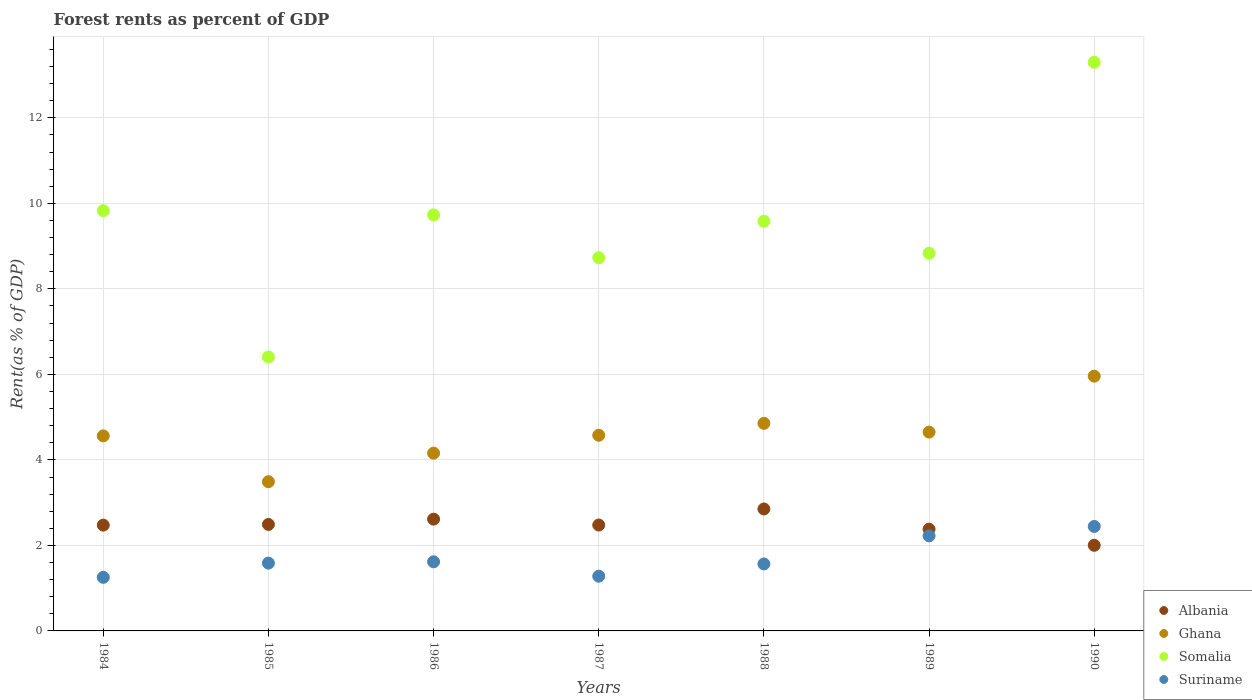What is the forest rent in Ghana in 1990?
Offer a very short reply. 5.96. Across all years, what is the maximum forest rent in Suriname?
Your answer should be very brief. 2.44. Across all years, what is the minimum forest rent in Ghana?
Keep it short and to the point. 3.49. In which year was the forest rent in Ghana maximum?
Keep it short and to the point. 1990. What is the total forest rent in Ghana in the graph?
Offer a very short reply. 32.25. What is the difference between the forest rent in Albania in 1986 and that in 1989?
Ensure brevity in your answer.  0.23. What is the difference between the forest rent in Suriname in 1986 and the forest rent in Somalia in 1987?
Give a very brief answer. -7.11. What is the average forest rent in Somalia per year?
Ensure brevity in your answer.  9.49. In the year 1989, what is the difference between the forest rent in Suriname and forest rent in Ghana?
Your answer should be compact. -2.43. In how many years, is the forest rent in Albania greater than 1.6 %?
Your answer should be compact. 7. What is the ratio of the forest rent in Somalia in 1985 to that in 1988?
Provide a succinct answer. 0.67. Is the forest rent in Albania in 1985 less than that in 1990?
Ensure brevity in your answer.  No. Is the difference between the forest rent in Suriname in 1985 and 1990 greater than the difference between the forest rent in Ghana in 1985 and 1990?
Your answer should be compact. Yes. What is the difference between the highest and the second highest forest rent in Albania?
Ensure brevity in your answer.  0.24. What is the difference between the highest and the lowest forest rent in Albania?
Ensure brevity in your answer.  0.85. Is it the case that in every year, the sum of the forest rent in Somalia and forest rent in Suriname  is greater than the sum of forest rent in Albania and forest rent in Ghana?
Your answer should be very brief. No. Does the forest rent in Albania monotonically increase over the years?
Your response must be concise. No. Is the forest rent in Ghana strictly less than the forest rent in Somalia over the years?
Your answer should be compact. Yes. How many dotlines are there?
Provide a short and direct response. 4. Does the graph contain any zero values?
Offer a very short reply. No. Does the graph contain grids?
Offer a very short reply. Yes. Where does the legend appear in the graph?
Keep it short and to the point. Bottom right. How many legend labels are there?
Give a very brief answer. 4. How are the legend labels stacked?
Provide a short and direct response. Vertical. What is the title of the graph?
Your answer should be very brief. Forest rents as percent of GDP. What is the label or title of the Y-axis?
Your answer should be compact. Rent(as % of GDP). What is the Rent(as % of GDP) of Albania in 1984?
Provide a short and direct response. 2.47. What is the Rent(as % of GDP) of Ghana in 1984?
Make the answer very short. 4.56. What is the Rent(as % of GDP) of Somalia in 1984?
Ensure brevity in your answer.  9.83. What is the Rent(as % of GDP) of Suriname in 1984?
Offer a very short reply. 1.25. What is the Rent(as % of GDP) of Albania in 1985?
Ensure brevity in your answer.  2.49. What is the Rent(as % of GDP) of Ghana in 1985?
Offer a terse response. 3.49. What is the Rent(as % of GDP) of Somalia in 1985?
Keep it short and to the point. 6.41. What is the Rent(as % of GDP) of Suriname in 1985?
Keep it short and to the point. 1.59. What is the Rent(as % of GDP) of Albania in 1986?
Keep it short and to the point. 2.61. What is the Rent(as % of GDP) of Ghana in 1986?
Give a very brief answer. 4.16. What is the Rent(as % of GDP) in Somalia in 1986?
Offer a terse response. 9.73. What is the Rent(as % of GDP) of Suriname in 1986?
Provide a succinct answer. 1.62. What is the Rent(as % of GDP) of Albania in 1987?
Offer a very short reply. 2.48. What is the Rent(as % of GDP) in Ghana in 1987?
Provide a succinct answer. 4.58. What is the Rent(as % of GDP) in Somalia in 1987?
Provide a short and direct response. 8.73. What is the Rent(as % of GDP) of Suriname in 1987?
Keep it short and to the point. 1.28. What is the Rent(as % of GDP) of Albania in 1988?
Provide a succinct answer. 2.85. What is the Rent(as % of GDP) of Ghana in 1988?
Provide a short and direct response. 4.85. What is the Rent(as % of GDP) in Somalia in 1988?
Your answer should be compact. 9.58. What is the Rent(as % of GDP) in Suriname in 1988?
Keep it short and to the point. 1.57. What is the Rent(as % of GDP) of Albania in 1989?
Ensure brevity in your answer.  2.38. What is the Rent(as % of GDP) in Ghana in 1989?
Your response must be concise. 4.65. What is the Rent(as % of GDP) in Somalia in 1989?
Make the answer very short. 8.83. What is the Rent(as % of GDP) in Suriname in 1989?
Keep it short and to the point. 2.22. What is the Rent(as % of GDP) in Albania in 1990?
Provide a succinct answer. 2. What is the Rent(as % of GDP) of Ghana in 1990?
Offer a terse response. 5.96. What is the Rent(as % of GDP) of Somalia in 1990?
Offer a very short reply. 13.3. What is the Rent(as % of GDP) of Suriname in 1990?
Provide a short and direct response. 2.44. Across all years, what is the maximum Rent(as % of GDP) in Albania?
Your answer should be compact. 2.85. Across all years, what is the maximum Rent(as % of GDP) of Ghana?
Keep it short and to the point. 5.96. Across all years, what is the maximum Rent(as % of GDP) of Somalia?
Keep it short and to the point. 13.3. Across all years, what is the maximum Rent(as % of GDP) of Suriname?
Make the answer very short. 2.44. Across all years, what is the minimum Rent(as % of GDP) of Albania?
Offer a terse response. 2. Across all years, what is the minimum Rent(as % of GDP) in Ghana?
Provide a succinct answer. 3.49. Across all years, what is the minimum Rent(as % of GDP) in Somalia?
Offer a terse response. 6.41. Across all years, what is the minimum Rent(as % of GDP) in Suriname?
Provide a succinct answer. 1.25. What is the total Rent(as % of GDP) in Albania in the graph?
Make the answer very short. 17.29. What is the total Rent(as % of GDP) of Ghana in the graph?
Keep it short and to the point. 32.25. What is the total Rent(as % of GDP) in Somalia in the graph?
Give a very brief answer. 66.41. What is the total Rent(as % of GDP) of Suriname in the graph?
Ensure brevity in your answer.  11.97. What is the difference between the Rent(as % of GDP) in Albania in 1984 and that in 1985?
Ensure brevity in your answer.  -0.02. What is the difference between the Rent(as % of GDP) in Ghana in 1984 and that in 1985?
Your answer should be compact. 1.07. What is the difference between the Rent(as % of GDP) in Somalia in 1984 and that in 1985?
Your answer should be compact. 3.42. What is the difference between the Rent(as % of GDP) of Suriname in 1984 and that in 1985?
Offer a very short reply. -0.33. What is the difference between the Rent(as % of GDP) in Albania in 1984 and that in 1986?
Provide a short and direct response. -0.14. What is the difference between the Rent(as % of GDP) of Ghana in 1984 and that in 1986?
Your answer should be very brief. 0.4. What is the difference between the Rent(as % of GDP) in Somalia in 1984 and that in 1986?
Make the answer very short. 0.1. What is the difference between the Rent(as % of GDP) of Suriname in 1984 and that in 1986?
Make the answer very short. -0.36. What is the difference between the Rent(as % of GDP) of Albania in 1984 and that in 1987?
Ensure brevity in your answer.  -0. What is the difference between the Rent(as % of GDP) of Ghana in 1984 and that in 1987?
Provide a short and direct response. -0.01. What is the difference between the Rent(as % of GDP) of Somalia in 1984 and that in 1987?
Ensure brevity in your answer.  1.1. What is the difference between the Rent(as % of GDP) in Suriname in 1984 and that in 1987?
Give a very brief answer. -0.03. What is the difference between the Rent(as % of GDP) in Albania in 1984 and that in 1988?
Your response must be concise. -0.38. What is the difference between the Rent(as % of GDP) of Ghana in 1984 and that in 1988?
Your response must be concise. -0.29. What is the difference between the Rent(as % of GDP) in Somalia in 1984 and that in 1988?
Your answer should be compact. 0.25. What is the difference between the Rent(as % of GDP) of Suriname in 1984 and that in 1988?
Keep it short and to the point. -0.31. What is the difference between the Rent(as % of GDP) in Albania in 1984 and that in 1989?
Ensure brevity in your answer.  0.09. What is the difference between the Rent(as % of GDP) in Ghana in 1984 and that in 1989?
Provide a succinct answer. -0.09. What is the difference between the Rent(as % of GDP) of Suriname in 1984 and that in 1989?
Keep it short and to the point. -0.97. What is the difference between the Rent(as % of GDP) of Albania in 1984 and that in 1990?
Keep it short and to the point. 0.47. What is the difference between the Rent(as % of GDP) of Ghana in 1984 and that in 1990?
Provide a short and direct response. -1.4. What is the difference between the Rent(as % of GDP) of Somalia in 1984 and that in 1990?
Provide a succinct answer. -3.47. What is the difference between the Rent(as % of GDP) in Suriname in 1984 and that in 1990?
Make the answer very short. -1.19. What is the difference between the Rent(as % of GDP) in Albania in 1985 and that in 1986?
Your answer should be compact. -0.12. What is the difference between the Rent(as % of GDP) in Ghana in 1985 and that in 1986?
Provide a succinct answer. -0.67. What is the difference between the Rent(as % of GDP) of Somalia in 1985 and that in 1986?
Provide a short and direct response. -3.33. What is the difference between the Rent(as % of GDP) in Suriname in 1985 and that in 1986?
Provide a short and direct response. -0.03. What is the difference between the Rent(as % of GDP) of Albania in 1985 and that in 1987?
Your response must be concise. 0.01. What is the difference between the Rent(as % of GDP) in Ghana in 1985 and that in 1987?
Provide a succinct answer. -1.09. What is the difference between the Rent(as % of GDP) of Somalia in 1985 and that in 1987?
Make the answer very short. -2.32. What is the difference between the Rent(as % of GDP) of Suriname in 1985 and that in 1987?
Ensure brevity in your answer.  0.31. What is the difference between the Rent(as % of GDP) in Albania in 1985 and that in 1988?
Make the answer very short. -0.36. What is the difference between the Rent(as % of GDP) in Ghana in 1985 and that in 1988?
Your answer should be very brief. -1.37. What is the difference between the Rent(as % of GDP) of Somalia in 1985 and that in 1988?
Keep it short and to the point. -3.17. What is the difference between the Rent(as % of GDP) of Suriname in 1985 and that in 1988?
Give a very brief answer. 0.02. What is the difference between the Rent(as % of GDP) in Albania in 1985 and that in 1989?
Offer a very short reply. 0.11. What is the difference between the Rent(as % of GDP) in Ghana in 1985 and that in 1989?
Make the answer very short. -1.16. What is the difference between the Rent(as % of GDP) of Somalia in 1985 and that in 1989?
Your response must be concise. -2.43. What is the difference between the Rent(as % of GDP) of Suriname in 1985 and that in 1989?
Your answer should be very brief. -0.64. What is the difference between the Rent(as % of GDP) of Albania in 1985 and that in 1990?
Provide a short and direct response. 0.49. What is the difference between the Rent(as % of GDP) of Ghana in 1985 and that in 1990?
Keep it short and to the point. -2.47. What is the difference between the Rent(as % of GDP) in Somalia in 1985 and that in 1990?
Your answer should be very brief. -6.89. What is the difference between the Rent(as % of GDP) of Suriname in 1985 and that in 1990?
Keep it short and to the point. -0.86. What is the difference between the Rent(as % of GDP) in Albania in 1986 and that in 1987?
Your answer should be compact. 0.14. What is the difference between the Rent(as % of GDP) in Ghana in 1986 and that in 1987?
Provide a succinct answer. -0.42. What is the difference between the Rent(as % of GDP) in Somalia in 1986 and that in 1987?
Your answer should be very brief. 1. What is the difference between the Rent(as % of GDP) of Suriname in 1986 and that in 1987?
Your answer should be very brief. 0.34. What is the difference between the Rent(as % of GDP) of Albania in 1986 and that in 1988?
Offer a terse response. -0.24. What is the difference between the Rent(as % of GDP) of Ghana in 1986 and that in 1988?
Give a very brief answer. -0.7. What is the difference between the Rent(as % of GDP) of Somalia in 1986 and that in 1988?
Give a very brief answer. 0.15. What is the difference between the Rent(as % of GDP) in Suriname in 1986 and that in 1988?
Offer a very short reply. 0.05. What is the difference between the Rent(as % of GDP) in Albania in 1986 and that in 1989?
Give a very brief answer. 0.23. What is the difference between the Rent(as % of GDP) in Ghana in 1986 and that in 1989?
Offer a terse response. -0.49. What is the difference between the Rent(as % of GDP) of Somalia in 1986 and that in 1989?
Your answer should be very brief. 0.9. What is the difference between the Rent(as % of GDP) of Suriname in 1986 and that in 1989?
Provide a short and direct response. -0.61. What is the difference between the Rent(as % of GDP) in Albania in 1986 and that in 1990?
Offer a very short reply. 0.61. What is the difference between the Rent(as % of GDP) of Ghana in 1986 and that in 1990?
Keep it short and to the point. -1.8. What is the difference between the Rent(as % of GDP) in Somalia in 1986 and that in 1990?
Your response must be concise. -3.57. What is the difference between the Rent(as % of GDP) in Suriname in 1986 and that in 1990?
Provide a short and direct response. -0.83. What is the difference between the Rent(as % of GDP) in Albania in 1987 and that in 1988?
Make the answer very short. -0.38. What is the difference between the Rent(as % of GDP) of Ghana in 1987 and that in 1988?
Keep it short and to the point. -0.28. What is the difference between the Rent(as % of GDP) of Somalia in 1987 and that in 1988?
Ensure brevity in your answer.  -0.85. What is the difference between the Rent(as % of GDP) of Suriname in 1987 and that in 1988?
Your answer should be very brief. -0.29. What is the difference between the Rent(as % of GDP) in Albania in 1987 and that in 1989?
Provide a succinct answer. 0.1. What is the difference between the Rent(as % of GDP) in Ghana in 1987 and that in 1989?
Ensure brevity in your answer.  -0.07. What is the difference between the Rent(as % of GDP) in Somalia in 1987 and that in 1989?
Offer a terse response. -0.1. What is the difference between the Rent(as % of GDP) in Suriname in 1987 and that in 1989?
Ensure brevity in your answer.  -0.94. What is the difference between the Rent(as % of GDP) of Albania in 1987 and that in 1990?
Keep it short and to the point. 0.47. What is the difference between the Rent(as % of GDP) of Ghana in 1987 and that in 1990?
Your answer should be very brief. -1.38. What is the difference between the Rent(as % of GDP) of Somalia in 1987 and that in 1990?
Give a very brief answer. -4.57. What is the difference between the Rent(as % of GDP) of Suriname in 1987 and that in 1990?
Your answer should be very brief. -1.16. What is the difference between the Rent(as % of GDP) of Albania in 1988 and that in 1989?
Your answer should be very brief. 0.47. What is the difference between the Rent(as % of GDP) in Ghana in 1988 and that in 1989?
Keep it short and to the point. 0.2. What is the difference between the Rent(as % of GDP) in Somalia in 1988 and that in 1989?
Give a very brief answer. 0.75. What is the difference between the Rent(as % of GDP) of Suriname in 1988 and that in 1989?
Give a very brief answer. -0.66. What is the difference between the Rent(as % of GDP) in Albania in 1988 and that in 1990?
Make the answer very short. 0.85. What is the difference between the Rent(as % of GDP) of Ghana in 1988 and that in 1990?
Offer a terse response. -1.1. What is the difference between the Rent(as % of GDP) in Somalia in 1988 and that in 1990?
Provide a succinct answer. -3.72. What is the difference between the Rent(as % of GDP) of Suriname in 1988 and that in 1990?
Offer a very short reply. -0.88. What is the difference between the Rent(as % of GDP) of Albania in 1989 and that in 1990?
Give a very brief answer. 0.38. What is the difference between the Rent(as % of GDP) in Ghana in 1989 and that in 1990?
Keep it short and to the point. -1.31. What is the difference between the Rent(as % of GDP) of Somalia in 1989 and that in 1990?
Keep it short and to the point. -4.47. What is the difference between the Rent(as % of GDP) of Suriname in 1989 and that in 1990?
Your answer should be compact. -0.22. What is the difference between the Rent(as % of GDP) of Albania in 1984 and the Rent(as % of GDP) of Ghana in 1985?
Your answer should be very brief. -1.02. What is the difference between the Rent(as % of GDP) of Albania in 1984 and the Rent(as % of GDP) of Somalia in 1985?
Keep it short and to the point. -3.93. What is the difference between the Rent(as % of GDP) of Albania in 1984 and the Rent(as % of GDP) of Suriname in 1985?
Make the answer very short. 0.89. What is the difference between the Rent(as % of GDP) in Ghana in 1984 and the Rent(as % of GDP) in Somalia in 1985?
Your answer should be compact. -1.84. What is the difference between the Rent(as % of GDP) in Ghana in 1984 and the Rent(as % of GDP) in Suriname in 1985?
Give a very brief answer. 2.98. What is the difference between the Rent(as % of GDP) of Somalia in 1984 and the Rent(as % of GDP) of Suriname in 1985?
Provide a short and direct response. 8.24. What is the difference between the Rent(as % of GDP) of Albania in 1984 and the Rent(as % of GDP) of Ghana in 1986?
Give a very brief answer. -1.68. What is the difference between the Rent(as % of GDP) in Albania in 1984 and the Rent(as % of GDP) in Somalia in 1986?
Your answer should be very brief. -7.26. What is the difference between the Rent(as % of GDP) in Albania in 1984 and the Rent(as % of GDP) in Suriname in 1986?
Your answer should be very brief. 0.86. What is the difference between the Rent(as % of GDP) in Ghana in 1984 and the Rent(as % of GDP) in Somalia in 1986?
Keep it short and to the point. -5.17. What is the difference between the Rent(as % of GDP) in Ghana in 1984 and the Rent(as % of GDP) in Suriname in 1986?
Your answer should be compact. 2.95. What is the difference between the Rent(as % of GDP) in Somalia in 1984 and the Rent(as % of GDP) in Suriname in 1986?
Your answer should be compact. 8.21. What is the difference between the Rent(as % of GDP) of Albania in 1984 and the Rent(as % of GDP) of Ghana in 1987?
Your answer should be compact. -2.1. What is the difference between the Rent(as % of GDP) in Albania in 1984 and the Rent(as % of GDP) in Somalia in 1987?
Offer a terse response. -6.26. What is the difference between the Rent(as % of GDP) of Albania in 1984 and the Rent(as % of GDP) of Suriname in 1987?
Provide a succinct answer. 1.19. What is the difference between the Rent(as % of GDP) in Ghana in 1984 and the Rent(as % of GDP) in Somalia in 1987?
Keep it short and to the point. -4.17. What is the difference between the Rent(as % of GDP) in Ghana in 1984 and the Rent(as % of GDP) in Suriname in 1987?
Your answer should be very brief. 3.28. What is the difference between the Rent(as % of GDP) in Somalia in 1984 and the Rent(as % of GDP) in Suriname in 1987?
Offer a terse response. 8.55. What is the difference between the Rent(as % of GDP) of Albania in 1984 and the Rent(as % of GDP) of Ghana in 1988?
Your answer should be very brief. -2.38. What is the difference between the Rent(as % of GDP) of Albania in 1984 and the Rent(as % of GDP) of Somalia in 1988?
Ensure brevity in your answer.  -7.11. What is the difference between the Rent(as % of GDP) in Albania in 1984 and the Rent(as % of GDP) in Suriname in 1988?
Your answer should be compact. 0.91. What is the difference between the Rent(as % of GDP) of Ghana in 1984 and the Rent(as % of GDP) of Somalia in 1988?
Your answer should be very brief. -5.02. What is the difference between the Rent(as % of GDP) of Ghana in 1984 and the Rent(as % of GDP) of Suriname in 1988?
Your response must be concise. 3. What is the difference between the Rent(as % of GDP) in Somalia in 1984 and the Rent(as % of GDP) in Suriname in 1988?
Give a very brief answer. 8.26. What is the difference between the Rent(as % of GDP) of Albania in 1984 and the Rent(as % of GDP) of Ghana in 1989?
Keep it short and to the point. -2.18. What is the difference between the Rent(as % of GDP) of Albania in 1984 and the Rent(as % of GDP) of Somalia in 1989?
Your answer should be very brief. -6.36. What is the difference between the Rent(as % of GDP) in Albania in 1984 and the Rent(as % of GDP) in Suriname in 1989?
Your answer should be compact. 0.25. What is the difference between the Rent(as % of GDP) in Ghana in 1984 and the Rent(as % of GDP) in Somalia in 1989?
Your response must be concise. -4.27. What is the difference between the Rent(as % of GDP) in Ghana in 1984 and the Rent(as % of GDP) in Suriname in 1989?
Provide a succinct answer. 2.34. What is the difference between the Rent(as % of GDP) of Somalia in 1984 and the Rent(as % of GDP) of Suriname in 1989?
Give a very brief answer. 7.61. What is the difference between the Rent(as % of GDP) of Albania in 1984 and the Rent(as % of GDP) of Ghana in 1990?
Make the answer very short. -3.48. What is the difference between the Rent(as % of GDP) of Albania in 1984 and the Rent(as % of GDP) of Somalia in 1990?
Offer a terse response. -10.82. What is the difference between the Rent(as % of GDP) of Albania in 1984 and the Rent(as % of GDP) of Suriname in 1990?
Your response must be concise. 0.03. What is the difference between the Rent(as % of GDP) of Ghana in 1984 and the Rent(as % of GDP) of Somalia in 1990?
Your response must be concise. -8.74. What is the difference between the Rent(as % of GDP) of Ghana in 1984 and the Rent(as % of GDP) of Suriname in 1990?
Offer a very short reply. 2.12. What is the difference between the Rent(as % of GDP) in Somalia in 1984 and the Rent(as % of GDP) in Suriname in 1990?
Offer a terse response. 7.39. What is the difference between the Rent(as % of GDP) of Albania in 1985 and the Rent(as % of GDP) of Ghana in 1986?
Your answer should be very brief. -1.67. What is the difference between the Rent(as % of GDP) of Albania in 1985 and the Rent(as % of GDP) of Somalia in 1986?
Your answer should be compact. -7.24. What is the difference between the Rent(as % of GDP) in Albania in 1985 and the Rent(as % of GDP) in Suriname in 1986?
Give a very brief answer. 0.87. What is the difference between the Rent(as % of GDP) of Ghana in 1985 and the Rent(as % of GDP) of Somalia in 1986?
Give a very brief answer. -6.24. What is the difference between the Rent(as % of GDP) in Ghana in 1985 and the Rent(as % of GDP) in Suriname in 1986?
Your answer should be very brief. 1.87. What is the difference between the Rent(as % of GDP) in Somalia in 1985 and the Rent(as % of GDP) in Suriname in 1986?
Ensure brevity in your answer.  4.79. What is the difference between the Rent(as % of GDP) of Albania in 1985 and the Rent(as % of GDP) of Ghana in 1987?
Your answer should be compact. -2.09. What is the difference between the Rent(as % of GDP) of Albania in 1985 and the Rent(as % of GDP) of Somalia in 1987?
Your answer should be compact. -6.24. What is the difference between the Rent(as % of GDP) of Albania in 1985 and the Rent(as % of GDP) of Suriname in 1987?
Your response must be concise. 1.21. What is the difference between the Rent(as % of GDP) of Ghana in 1985 and the Rent(as % of GDP) of Somalia in 1987?
Your response must be concise. -5.24. What is the difference between the Rent(as % of GDP) in Ghana in 1985 and the Rent(as % of GDP) in Suriname in 1987?
Give a very brief answer. 2.21. What is the difference between the Rent(as % of GDP) of Somalia in 1985 and the Rent(as % of GDP) of Suriname in 1987?
Provide a succinct answer. 5.13. What is the difference between the Rent(as % of GDP) of Albania in 1985 and the Rent(as % of GDP) of Ghana in 1988?
Keep it short and to the point. -2.36. What is the difference between the Rent(as % of GDP) in Albania in 1985 and the Rent(as % of GDP) in Somalia in 1988?
Your response must be concise. -7.09. What is the difference between the Rent(as % of GDP) in Albania in 1985 and the Rent(as % of GDP) in Suriname in 1988?
Ensure brevity in your answer.  0.92. What is the difference between the Rent(as % of GDP) of Ghana in 1985 and the Rent(as % of GDP) of Somalia in 1988?
Make the answer very short. -6.09. What is the difference between the Rent(as % of GDP) in Ghana in 1985 and the Rent(as % of GDP) in Suriname in 1988?
Offer a very short reply. 1.92. What is the difference between the Rent(as % of GDP) of Somalia in 1985 and the Rent(as % of GDP) of Suriname in 1988?
Your response must be concise. 4.84. What is the difference between the Rent(as % of GDP) of Albania in 1985 and the Rent(as % of GDP) of Ghana in 1989?
Your response must be concise. -2.16. What is the difference between the Rent(as % of GDP) of Albania in 1985 and the Rent(as % of GDP) of Somalia in 1989?
Offer a terse response. -6.34. What is the difference between the Rent(as % of GDP) in Albania in 1985 and the Rent(as % of GDP) in Suriname in 1989?
Provide a short and direct response. 0.27. What is the difference between the Rent(as % of GDP) in Ghana in 1985 and the Rent(as % of GDP) in Somalia in 1989?
Provide a succinct answer. -5.34. What is the difference between the Rent(as % of GDP) of Ghana in 1985 and the Rent(as % of GDP) of Suriname in 1989?
Your response must be concise. 1.27. What is the difference between the Rent(as % of GDP) of Somalia in 1985 and the Rent(as % of GDP) of Suriname in 1989?
Provide a succinct answer. 4.18. What is the difference between the Rent(as % of GDP) in Albania in 1985 and the Rent(as % of GDP) in Ghana in 1990?
Make the answer very short. -3.47. What is the difference between the Rent(as % of GDP) in Albania in 1985 and the Rent(as % of GDP) in Somalia in 1990?
Offer a terse response. -10.81. What is the difference between the Rent(as % of GDP) in Albania in 1985 and the Rent(as % of GDP) in Suriname in 1990?
Provide a succinct answer. 0.05. What is the difference between the Rent(as % of GDP) in Ghana in 1985 and the Rent(as % of GDP) in Somalia in 1990?
Your response must be concise. -9.81. What is the difference between the Rent(as % of GDP) of Ghana in 1985 and the Rent(as % of GDP) of Suriname in 1990?
Provide a short and direct response. 1.05. What is the difference between the Rent(as % of GDP) in Somalia in 1985 and the Rent(as % of GDP) in Suriname in 1990?
Provide a succinct answer. 3.96. What is the difference between the Rent(as % of GDP) in Albania in 1986 and the Rent(as % of GDP) in Ghana in 1987?
Offer a terse response. -1.96. What is the difference between the Rent(as % of GDP) in Albania in 1986 and the Rent(as % of GDP) in Somalia in 1987?
Provide a succinct answer. -6.12. What is the difference between the Rent(as % of GDP) in Albania in 1986 and the Rent(as % of GDP) in Suriname in 1987?
Offer a very short reply. 1.33. What is the difference between the Rent(as % of GDP) in Ghana in 1986 and the Rent(as % of GDP) in Somalia in 1987?
Give a very brief answer. -4.57. What is the difference between the Rent(as % of GDP) in Ghana in 1986 and the Rent(as % of GDP) in Suriname in 1987?
Your answer should be very brief. 2.88. What is the difference between the Rent(as % of GDP) in Somalia in 1986 and the Rent(as % of GDP) in Suriname in 1987?
Give a very brief answer. 8.45. What is the difference between the Rent(as % of GDP) of Albania in 1986 and the Rent(as % of GDP) of Ghana in 1988?
Offer a terse response. -2.24. What is the difference between the Rent(as % of GDP) in Albania in 1986 and the Rent(as % of GDP) in Somalia in 1988?
Make the answer very short. -6.97. What is the difference between the Rent(as % of GDP) of Albania in 1986 and the Rent(as % of GDP) of Suriname in 1988?
Give a very brief answer. 1.05. What is the difference between the Rent(as % of GDP) in Ghana in 1986 and the Rent(as % of GDP) in Somalia in 1988?
Your answer should be very brief. -5.42. What is the difference between the Rent(as % of GDP) of Ghana in 1986 and the Rent(as % of GDP) of Suriname in 1988?
Keep it short and to the point. 2.59. What is the difference between the Rent(as % of GDP) of Somalia in 1986 and the Rent(as % of GDP) of Suriname in 1988?
Your answer should be very brief. 8.17. What is the difference between the Rent(as % of GDP) of Albania in 1986 and the Rent(as % of GDP) of Ghana in 1989?
Give a very brief answer. -2.04. What is the difference between the Rent(as % of GDP) of Albania in 1986 and the Rent(as % of GDP) of Somalia in 1989?
Provide a succinct answer. -6.22. What is the difference between the Rent(as % of GDP) of Albania in 1986 and the Rent(as % of GDP) of Suriname in 1989?
Provide a short and direct response. 0.39. What is the difference between the Rent(as % of GDP) in Ghana in 1986 and the Rent(as % of GDP) in Somalia in 1989?
Give a very brief answer. -4.68. What is the difference between the Rent(as % of GDP) in Ghana in 1986 and the Rent(as % of GDP) in Suriname in 1989?
Give a very brief answer. 1.93. What is the difference between the Rent(as % of GDP) in Somalia in 1986 and the Rent(as % of GDP) in Suriname in 1989?
Provide a short and direct response. 7.51. What is the difference between the Rent(as % of GDP) in Albania in 1986 and the Rent(as % of GDP) in Ghana in 1990?
Offer a very short reply. -3.34. What is the difference between the Rent(as % of GDP) in Albania in 1986 and the Rent(as % of GDP) in Somalia in 1990?
Provide a succinct answer. -10.68. What is the difference between the Rent(as % of GDP) of Albania in 1986 and the Rent(as % of GDP) of Suriname in 1990?
Give a very brief answer. 0.17. What is the difference between the Rent(as % of GDP) in Ghana in 1986 and the Rent(as % of GDP) in Somalia in 1990?
Provide a short and direct response. -9.14. What is the difference between the Rent(as % of GDP) in Ghana in 1986 and the Rent(as % of GDP) in Suriname in 1990?
Your answer should be compact. 1.71. What is the difference between the Rent(as % of GDP) in Somalia in 1986 and the Rent(as % of GDP) in Suriname in 1990?
Your answer should be compact. 7.29. What is the difference between the Rent(as % of GDP) in Albania in 1987 and the Rent(as % of GDP) in Ghana in 1988?
Make the answer very short. -2.38. What is the difference between the Rent(as % of GDP) in Albania in 1987 and the Rent(as % of GDP) in Somalia in 1988?
Your answer should be very brief. -7.1. What is the difference between the Rent(as % of GDP) of Albania in 1987 and the Rent(as % of GDP) of Suriname in 1988?
Your response must be concise. 0.91. What is the difference between the Rent(as % of GDP) of Ghana in 1987 and the Rent(as % of GDP) of Somalia in 1988?
Give a very brief answer. -5. What is the difference between the Rent(as % of GDP) in Ghana in 1987 and the Rent(as % of GDP) in Suriname in 1988?
Provide a succinct answer. 3.01. What is the difference between the Rent(as % of GDP) in Somalia in 1987 and the Rent(as % of GDP) in Suriname in 1988?
Offer a very short reply. 7.16. What is the difference between the Rent(as % of GDP) in Albania in 1987 and the Rent(as % of GDP) in Ghana in 1989?
Offer a terse response. -2.17. What is the difference between the Rent(as % of GDP) in Albania in 1987 and the Rent(as % of GDP) in Somalia in 1989?
Offer a very short reply. -6.36. What is the difference between the Rent(as % of GDP) of Albania in 1987 and the Rent(as % of GDP) of Suriname in 1989?
Keep it short and to the point. 0.25. What is the difference between the Rent(as % of GDP) of Ghana in 1987 and the Rent(as % of GDP) of Somalia in 1989?
Offer a terse response. -4.26. What is the difference between the Rent(as % of GDP) of Ghana in 1987 and the Rent(as % of GDP) of Suriname in 1989?
Your answer should be very brief. 2.35. What is the difference between the Rent(as % of GDP) in Somalia in 1987 and the Rent(as % of GDP) in Suriname in 1989?
Provide a short and direct response. 6.51. What is the difference between the Rent(as % of GDP) of Albania in 1987 and the Rent(as % of GDP) of Ghana in 1990?
Your answer should be compact. -3.48. What is the difference between the Rent(as % of GDP) of Albania in 1987 and the Rent(as % of GDP) of Somalia in 1990?
Make the answer very short. -10.82. What is the difference between the Rent(as % of GDP) of Albania in 1987 and the Rent(as % of GDP) of Suriname in 1990?
Offer a terse response. 0.03. What is the difference between the Rent(as % of GDP) in Ghana in 1987 and the Rent(as % of GDP) in Somalia in 1990?
Offer a terse response. -8.72. What is the difference between the Rent(as % of GDP) of Ghana in 1987 and the Rent(as % of GDP) of Suriname in 1990?
Keep it short and to the point. 2.13. What is the difference between the Rent(as % of GDP) in Somalia in 1987 and the Rent(as % of GDP) in Suriname in 1990?
Make the answer very short. 6.29. What is the difference between the Rent(as % of GDP) of Albania in 1988 and the Rent(as % of GDP) of Ghana in 1989?
Make the answer very short. -1.8. What is the difference between the Rent(as % of GDP) in Albania in 1988 and the Rent(as % of GDP) in Somalia in 1989?
Offer a terse response. -5.98. What is the difference between the Rent(as % of GDP) in Albania in 1988 and the Rent(as % of GDP) in Suriname in 1989?
Provide a succinct answer. 0.63. What is the difference between the Rent(as % of GDP) in Ghana in 1988 and the Rent(as % of GDP) in Somalia in 1989?
Your response must be concise. -3.98. What is the difference between the Rent(as % of GDP) of Ghana in 1988 and the Rent(as % of GDP) of Suriname in 1989?
Make the answer very short. 2.63. What is the difference between the Rent(as % of GDP) of Somalia in 1988 and the Rent(as % of GDP) of Suriname in 1989?
Your answer should be compact. 7.36. What is the difference between the Rent(as % of GDP) in Albania in 1988 and the Rent(as % of GDP) in Ghana in 1990?
Your response must be concise. -3.11. What is the difference between the Rent(as % of GDP) of Albania in 1988 and the Rent(as % of GDP) of Somalia in 1990?
Offer a terse response. -10.45. What is the difference between the Rent(as % of GDP) of Albania in 1988 and the Rent(as % of GDP) of Suriname in 1990?
Your answer should be very brief. 0.41. What is the difference between the Rent(as % of GDP) of Ghana in 1988 and the Rent(as % of GDP) of Somalia in 1990?
Keep it short and to the point. -8.44. What is the difference between the Rent(as % of GDP) in Ghana in 1988 and the Rent(as % of GDP) in Suriname in 1990?
Ensure brevity in your answer.  2.41. What is the difference between the Rent(as % of GDP) in Somalia in 1988 and the Rent(as % of GDP) in Suriname in 1990?
Your response must be concise. 7.14. What is the difference between the Rent(as % of GDP) of Albania in 1989 and the Rent(as % of GDP) of Ghana in 1990?
Your answer should be compact. -3.58. What is the difference between the Rent(as % of GDP) of Albania in 1989 and the Rent(as % of GDP) of Somalia in 1990?
Your answer should be compact. -10.92. What is the difference between the Rent(as % of GDP) of Albania in 1989 and the Rent(as % of GDP) of Suriname in 1990?
Your response must be concise. -0.06. What is the difference between the Rent(as % of GDP) of Ghana in 1989 and the Rent(as % of GDP) of Somalia in 1990?
Your answer should be very brief. -8.65. What is the difference between the Rent(as % of GDP) of Ghana in 1989 and the Rent(as % of GDP) of Suriname in 1990?
Your response must be concise. 2.21. What is the difference between the Rent(as % of GDP) in Somalia in 1989 and the Rent(as % of GDP) in Suriname in 1990?
Provide a short and direct response. 6.39. What is the average Rent(as % of GDP) in Albania per year?
Your answer should be compact. 2.47. What is the average Rent(as % of GDP) in Ghana per year?
Give a very brief answer. 4.61. What is the average Rent(as % of GDP) of Somalia per year?
Offer a very short reply. 9.49. What is the average Rent(as % of GDP) in Suriname per year?
Give a very brief answer. 1.71. In the year 1984, what is the difference between the Rent(as % of GDP) of Albania and Rent(as % of GDP) of Ghana?
Make the answer very short. -2.09. In the year 1984, what is the difference between the Rent(as % of GDP) of Albania and Rent(as % of GDP) of Somalia?
Provide a short and direct response. -7.36. In the year 1984, what is the difference between the Rent(as % of GDP) in Albania and Rent(as % of GDP) in Suriname?
Your response must be concise. 1.22. In the year 1984, what is the difference between the Rent(as % of GDP) of Ghana and Rent(as % of GDP) of Somalia?
Provide a succinct answer. -5.27. In the year 1984, what is the difference between the Rent(as % of GDP) of Ghana and Rent(as % of GDP) of Suriname?
Offer a terse response. 3.31. In the year 1984, what is the difference between the Rent(as % of GDP) in Somalia and Rent(as % of GDP) in Suriname?
Your answer should be compact. 8.58. In the year 1985, what is the difference between the Rent(as % of GDP) in Albania and Rent(as % of GDP) in Ghana?
Your answer should be compact. -1. In the year 1985, what is the difference between the Rent(as % of GDP) of Albania and Rent(as % of GDP) of Somalia?
Make the answer very short. -3.92. In the year 1985, what is the difference between the Rent(as % of GDP) of Albania and Rent(as % of GDP) of Suriname?
Offer a terse response. 0.9. In the year 1985, what is the difference between the Rent(as % of GDP) of Ghana and Rent(as % of GDP) of Somalia?
Your response must be concise. -2.92. In the year 1985, what is the difference between the Rent(as % of GDP) in Ghana and Rent(as % of GDP) in Suriname?
Offer a terse response. 1.9. In the year 1985, what is the difference between the Rent(as % of GDP) in Somalia and Rent(as % of GDP) in Suriname?
Provide a succinct answer. 4.82. In the year 1986, what is the difference between the Rent(as % of GDP) of Albania and Rent(as % of GDP) of Ghana?
Offer a very short reply. -1.54. In the year 1986, what is the difference between the Rent(as % of GDP) in Albania and Rent(as % of GDP) in Somalia?
Make the answer very short. -7.12. In the year 1986, what is the difference between the Rent(as % of GDP) of Albania and Rent(as % of GDP) of Suriname?
Provide a succinct answer. 1. In the year 1986, what is the difference between the Rent(as % of GDP) of Ghana and Rent(as % of GDP) of Somalia?
Give a very brief answer. -5.57. In the year 1986, what is the difference between the Rent(as % of GDP) in Ghana and Rent(as % of GDP) in Suriname?
Ensure brevity in your answer.  2.54. In the year 1986, what is the difference between the Rent(as % of GDP) in Somalia and Rent(as % of GDP) in Suriname?
Make the answer very short. 8.11. In the year 1987, what is the difference between the Rent(as % of GDP) of Albania and Rent(as % of GDP) of Ghana?
Keep it short and to the point. -2.1. In the year 1987, what is the difference between the Rent(as % of GDP) of Albania and Rent(as % of GDP) of Somalia?
Ensure brevity in your answer.  -6.25. In the year 1987, what is the difference between the Rent(as % of GDP) in Albania and Rent(as % of GDP) in Suriname?
Offer a very short reply. 1.2. In the year 1987, what is the difference between the Rent(as % of GDP) of Ghana and Rent(as % of GDP) of Somalia?
Your response must be concise. -4.15. In the year 1987, what is the difference between the Rent(as % of GDP) of Ghana and Rent(as % of GDP) of Suriname?
Keep it short and to the point. 3.3. In the year 1987, what is the difference between the Rent(as % of GDP) in Somalia and Rent(as % of GDP) in Suriname?
Offer a terse response. 7.45. In the year 1988, what is the difference between the Rent(as % of GDP) in Albania and Rent(as % of GDP) in Ghana?
Your response must be concise. -2. In the year 1988, what is the difference between the Rent(as % of GDP) in Albania and Rent(as % of GDP) in Somalia?
Offer a very short reply. -6.73. In the year 1988, what is the difference between the Rent(as % of GDP) of Albania and Rent(as % of GDP) of Suriname?
Your answer should be very brief. 1.29. In the year 1988, what is the difference between the Rent(as % of GDP) of Ghana and Rent(as % of GDP) of Somalia?
Make the answer very short. -4.73. In the year 1988, what is the difference between the Rent(as % of GDP) of Ghana and Rent(as % of GDP) of Suriname?
Provide a succinct answer. 3.29. In the year 1988, what is the difference between the Rent(as % of GDP) of Somalia and Rent(as % of GDP) of Suriname?
Your response must be concise. 8.01. In the year 1989, what is the difference between the Rent(as % of GDP) of Albania and Rent(as % of GDP) of Ghana?
Your answer should be compact. -2.27. In the year 1989, what is the difference between the Rent(as % of GDP) of Albania and Rent(as % of GDP) of Somalia?
Your response must be concise. -6.45. In the year 1989, what is the difference between the Rent(as % of GDP) of Albania and Rent(as % of GDP) of Suriname?
Ensure brevity in your answer.  0.16. In the year 1989, what is the difference between the Rent(as % of GDP) of Ghana and Rent(as % of GDP) of Somalia?
Provide a succinct answer. -4.18. In the year 1989, what is the difference between the Rent(as % of GDP) in Ghana and Rent(as % of GDP) in Suriname?
Offer a terse response. 2.43. In the year 1989, what is the difference between the Rent(as % of GDP) of Somalia and Rent(as % of GDP) of Suriname?
Offer a terse response. 6.61. In the year 1990, what is the difference between the Rent(as % of GDP) of Albania and Rent(as % of GDP) of Ghana?
Your answer should be very brief. -3.96. In the year 1990, what is the difference between the Rent(as % of GDP) of Albania and Rent(as % of GDP) of Somalia?
Your response must be concise. -11.3. In the year 1990, what is the difference between the Rent(as % of GDP) of Albania and Rent(as % of GDP) of Suriname?
Offer a terse response. -0.44. In the year 1990, what is the difference between the Rent(as % of GDP) of Ghana and Rent(as % of GDP) of Somalia?
Keep it short and to the point. -7.34. In the year 1990, what is the difference between the Rent(as % of GDP) in Ghana and Rent(as % of GDP) in Suriname?
Your answer should be very brief. 3.52. In the year 1990, what is the difference between the Rent(as % of GDP) of Somalia and Rent(as % of GDP) of Suriname?
Your response must be concise. 10.86. What is the ratio of the Rent(as % of GDP) in Albania in 1984 to that in 1985?
Provide a succinct answer. 0.99. What is the ratio of the Rent(as % of GDP) in Ghana in 1984 to that in 1985?
Your answer should be compact. 1.31. What is the ratio of the Rent(as % of GDP) of Somalia in 1984 to that in 1985?
Your answer should be compact. 1.53. What is the ratio of the Rent(as % of GDP) in Suriname in 1984 to that in 1985?
Your response must be concise. 0.79. What is the ratio of the Rent(as % of GDP) of Albania in 1984 to that in 1986?
Provide a short and direct response. 0.95. What is the ratio of the Rent(as % of GDP) of Ghana in 1984 to that in 1986?
Offer a very short reply. 1.1. What is the ratio of the Rent(as % of GDP) in Suriname in 1984 to that in 1986?
Keep it short and to the point. 0.78. What is the ratio of the Rent(as % of GDP) of Albania in 1984 to that in 1987?
Provide a short and direct response. 1. What is the ratio of the Rent(as % of GDP) in Ghana in 1984 to that in 1987?
Your response must be concise. 1. What is the ratio of the Rent(as % of GDP) in Somalia in 1984 to that in 1987?
Offer a terse response. 1.13. What is the ratio of the Rent(as % of GDP) of Suriname in 1984 to that in 1987?
Offer a very short reply. 0.98. What is the ratio of the Rent(as % of GDP) of Albania in 1984 to that in 1988?
Keep it short and to the point. 0.87. What is the ratio of the Rent(as % of GDP) of Ghana in 1984 to that in 1988?
Offer a terse response. 0.94. What is the ratio of the Rent(as % of GDP) of Somalia in 1984 to that in 1988?
Your response must be concise. 1.03. What is the ratio of the Rent(as % of GDP) in Suriname in 1984 to that in 1988?
Offer a terse response. 0.8. What is the ratio of the Rent(as % of GDP) in Albania in 1984 to that in 1989?
Provide a short and direct response. 1.04. What is the ratio of the Rent(as % of GDP) of Ghana in 1984 to that in 1989?
Provide a succinct answer. 0.98. What is the ratio of the Rent(as % of GDP) of Somalia in 1984 to that in 1989?
Your answer should be very brief. 1.11. What is the ratio of the Rent(as % of GDP) in Suriname in 1984 to that in 1989?
Ensure brevity in your answer.  0.56. What is the ratio of the Rent(as % of GDP) of Albania in 1984 to that in 1990?
Offer a terse response. 1.24. What is the ratio of the Rent(as % of GDP) of Ghana in 1984 to that in 1990?
Ensure brevity in your answer.  0.77. What is the ratio of the Rent(as % of GDP) in Somalia in 1984 to that in 1990?
Provide a short and direct response. 0.74. What is the ratio of the Rent(as % of GDP) of Suriname in 1984 to that in 1990?
Provide a short and direct response. 0.51. What is the ratio of the Rent(as % of GDP) in Albania in 1985 to that in 1986?
Provide a succinct answer. 0.95. What is the ratio of the Rent(as % of GDP) in Ghana in 1985 to that in 1986?
Provide a succinct answer. 0.84. What is the ratio of the Rent(as % of GDP) of Somalia in 1985 to that in 1986?
Your answer should be very brief. 0.66. What is the ratio of the Rent(as % of GDP) in Suriname in 1985 to that in 1986?
Offer a terse response. 0.98. What is the ratio of the Rent(as % of GDP) of Albania in 1985 to that in 1987?
Your answer should be compact. 1.01. What is the ratio of the Rent(as % of GDP) of Ghana in 1985 to that in 1987?
Provide a succinct answer. 0.76. What is the ratio of the Rent(as % of GDP) in Somalia in 1985 to that in 1987?
Your answer should be very brief. 0.73. What is the ratio of the Rent(as % of GDP) in Suriname in 1985 to that in 1987?
Make the answer very short. 1.24. What is the ratio of the Rent(as % of GDP) in Albania in 1985 to that in 1988?
Give a very brief answer. 0.87. What is the ratio of the Rent(as % of GDP) in Ghana in 1985 to that in 1988?
Your answer should be compact. 0.72. What is the ratio of the Rent(as % of GDP) of Somalia in 1985 to that in 1988?
Make the answer very short. 0.67. What is the ratio of the Rent(as % of GDP) of Suriname in 1985 to that in 1988?
Provide a short and direct response. 1.01. What is the ratio of the Rent(as % of GDP) in Albania in 1985 to that in 1989?
Provide a short and direct response. 1.05. What is the ratio of the Rent(as % of GDP) of Ghana in 1985 to that in 1989?
Your answer should be compact. 0.75. What is the ratio of the Rent(as % of GDP) of Somalia in 1985 to that in 1989?
Provide a short and direct response. 0.73. What is the ratio of the Rent(as % of GDP) in Suriname in 1985 to that in 1989?
Offer a terse response. 0.71. What is the ratio of the Rent(as % of GDP) of Albania in 1985 to that in 1990?
Give a very brief answer. 1.24. What is the ratio of the Rent(as % of GDP) in Ghana in 1985 to that in 1990?
Make the answer very short. 0.59. What is the ratio of the Rent(as % of GDP) in Somalia in 1985 to that in 1990?
Make the answer very short. 0.48. What is the ratio of the Rent(as % of GDP) in Suriname in 1985 to that in 1990?
Make the answer very short. 0.65. What is the ratio of the Rent(as % of GDP) in Albania in 1986 to that in 1987?
Your answer should be very brief. 1.06. What is the ratio of the Rent(as % of GDP) of Ghana in 1986 to that in 1987?
Your answer should be very brief. 0.91. What is the ratio of the Rent(as % of GDP) of Somalia in 1986 to that in 1987?
Make the answer very short. 1.11. What is the ratio of the Rent(as % of GDP) in Suriname in 1986 to that in 1987?
Provide a succinct answer. 1.26. What is the ratio of the Rent(as % of GDP) of Albania in 1986 to that in 1988?
Give a very brief answer. 0.92. What is the ratio of the Rent(as % of GDP) of Ghana in 1986 to that in 1988?
Provide a short and direct response. 0.86. What is the ratio of the Rent(as % of GDP) in Somalia in 1986 to that in 1988?
Make the answer very short. 1.02. What is the ratio of the Rent(as % of GDP) of Suriname in 1986 to that in 1988?
Your answer should be very brief. 1.03. What is the ratio of the Rent(as % of GDP) in Albania in 1986 to that in 1989?
Your answer should be compact. 1.1. What is the ratio of the Rent(as % of GDP) in Ghana in 1986 to that in 1989?
Keep it short and to the point. 0.89. What is the ratio of the Rent(as % of GDP) in Somalia in 1986 to that in 1989?
Your answer should be very brief. 1.1. What is the ratio of the Rent(as % of GDP) in Suriname in 1986 to that in 1989?
Your answer should be very brief. 0.73. What is the ratio of the Rent(as % of GDP) in Albania in 1986 to that in 1990?
Offer a very short reply. 1.31. What is the ratio of the Rent(as % of GDP) of Ghana in 1986 to that in 1990?
Your answer should be very brief. 0.7. What is the ratio of the Rent(as % of GDP) in Somalia in 1986 to that in 1990?
Offer a very short reply. 0.73. What is the ratio of the Rent(as % of GDP) of Suriname in 1986 to that in 1990?
Ensure brevity in your answer.  0.66. What is the ratio of the Rent(as % of GDP) of Albania in 1987 to that in 1988?
Your response must be concise. 0.87. What is the ratio of the Rent(as % of GDP) of Ghana in 1987 to that in 1988?
Your answer should be very brief. 0.94. What is the ratio of the Rent(as % of GDP) in Somalia in 1987 to that in 1988?
Keep it short and to the point. 0.91. What is the ratio of the Rent(as % of GDP) of Suriname in 1987 to that in 1988?
Keep it short and to the point. 0.82. What is the ratio of the Rent(as % of GDP) in Albania in 1987 to that in 1989?
Ensure brevity in your answer.  1.04. What is the ratio of the Rent(as % of GDP) of Ghana in 1987 to that in 1989?
Your answer should be compact. 0.98. What is the ratio of the Rent(as % of GDP) in Somalia in 1987 to that in 1989?
Provide a short and direct response. 0.99. What is the ratio of the Rent(as % of GDP) of Suriname in 1987 to that in 1989?
Provide a short and direct response. 0.58. What is the ratio of the Rent(as % of GDP) of Albania in 1987 to that in 1990?
Provide a succinct answer. 1.24. What is the ratio of the Rent(as % of GDP) of Ghana in 1987 to that in 1990?
Ensure brevity in your answer.  0.77. What is the ratio of the Rent(as % of GDP) of Somalia in 1987 to that in 1990?
Your answer should be compact. 0.66. What is the ratio of the Rent(as % of GDP) in Suriname in 1987 to that in 1990?
Offer a very short reply. 0.52. What is the ratio of the Rent(as % of GDP) of Albania in 1988 to that in 1989?
Ensure brevity in your answer.  1.2. What is the ratio of the Rent(as % of GDP) in Ghana in 1988 to that in 1989?
Provide a succinct answer. 1.04. What is the ratio of the Rent(as % of GDP) of Somalia in 1988 to that in 1989?
Your answer should be compact. 1.08. What is the ratio of the Rent(as % of GDP) in Suriname in 1988 to that in 1989?
Ensure brevity in your answer.  0.7. What is the ratio of the Rent(as % of GDP) in Albania in 1988 to that in 1990?
Your response must be concise. 1.42. What is the ratio of the Rent(as % of GDP) in Ghana in 1988 to that in 1990?
Your answer should be very brief. 0.81. What is the ratio of the Rent(as % of GDP) of Somalia in 1988 to that in 1990?
Provide a succinct answer. 0.72. What is the ratio of the Rent(as % of GDP) of Suriname in 1988 to that in 1990?
Your response must be concise. 0.64. What is the ratio of the Rent(as % of GDP) in Albania in 1989 to that in 1990?
Provide a short and direct response. 1.19. What is the ratio of the Rent(as % of GDP) of Ghana in 1989 to that in 1990?
Keep it short and to the point. 0.78. What is the ratio of the Rent(as % of GDP) in Somalia in 1989 to that in 1990?
Offer a very short reply. 0.66. What is the ratio of the Rent(as % of GDP) in Suriname in 1989 to that in 1990?
Ensure brevity in your answer.  0.91. What is the difference between the highest and the second highest Rent(as % of GDP) of Albania?
Offer a terse response. 0.24. What is the difference between the highest and the second highest Rent(as % of GDP) of Ghana?
Keep it short and to the point. 1.1. What is the difference between the highest and the second highest Rent(as % of GDP) in Somalia?
Your answer should be compact. 3.47. What is the difference between the highest and the second highest Rent(as % of GDP) in Suriname?
Offer a very short reply. 0.22. What is the difference between the highest and the lowest Rent(as % of GDP) of Albania?
Offer a very short reply. 0.85. What is the difference between the highest and the lowest Rent(as % of GDP) of Ghana?
Make the answer very short. 2.47. What is the difference between the highest and the lowest Rent(as % of GDP) of Somalia?
Your answer should be very brief. 6.89. What is the difference between the highest and the lowest Rent(as % of GDP) of Suriname?
Offer a terse response. 1.19. 